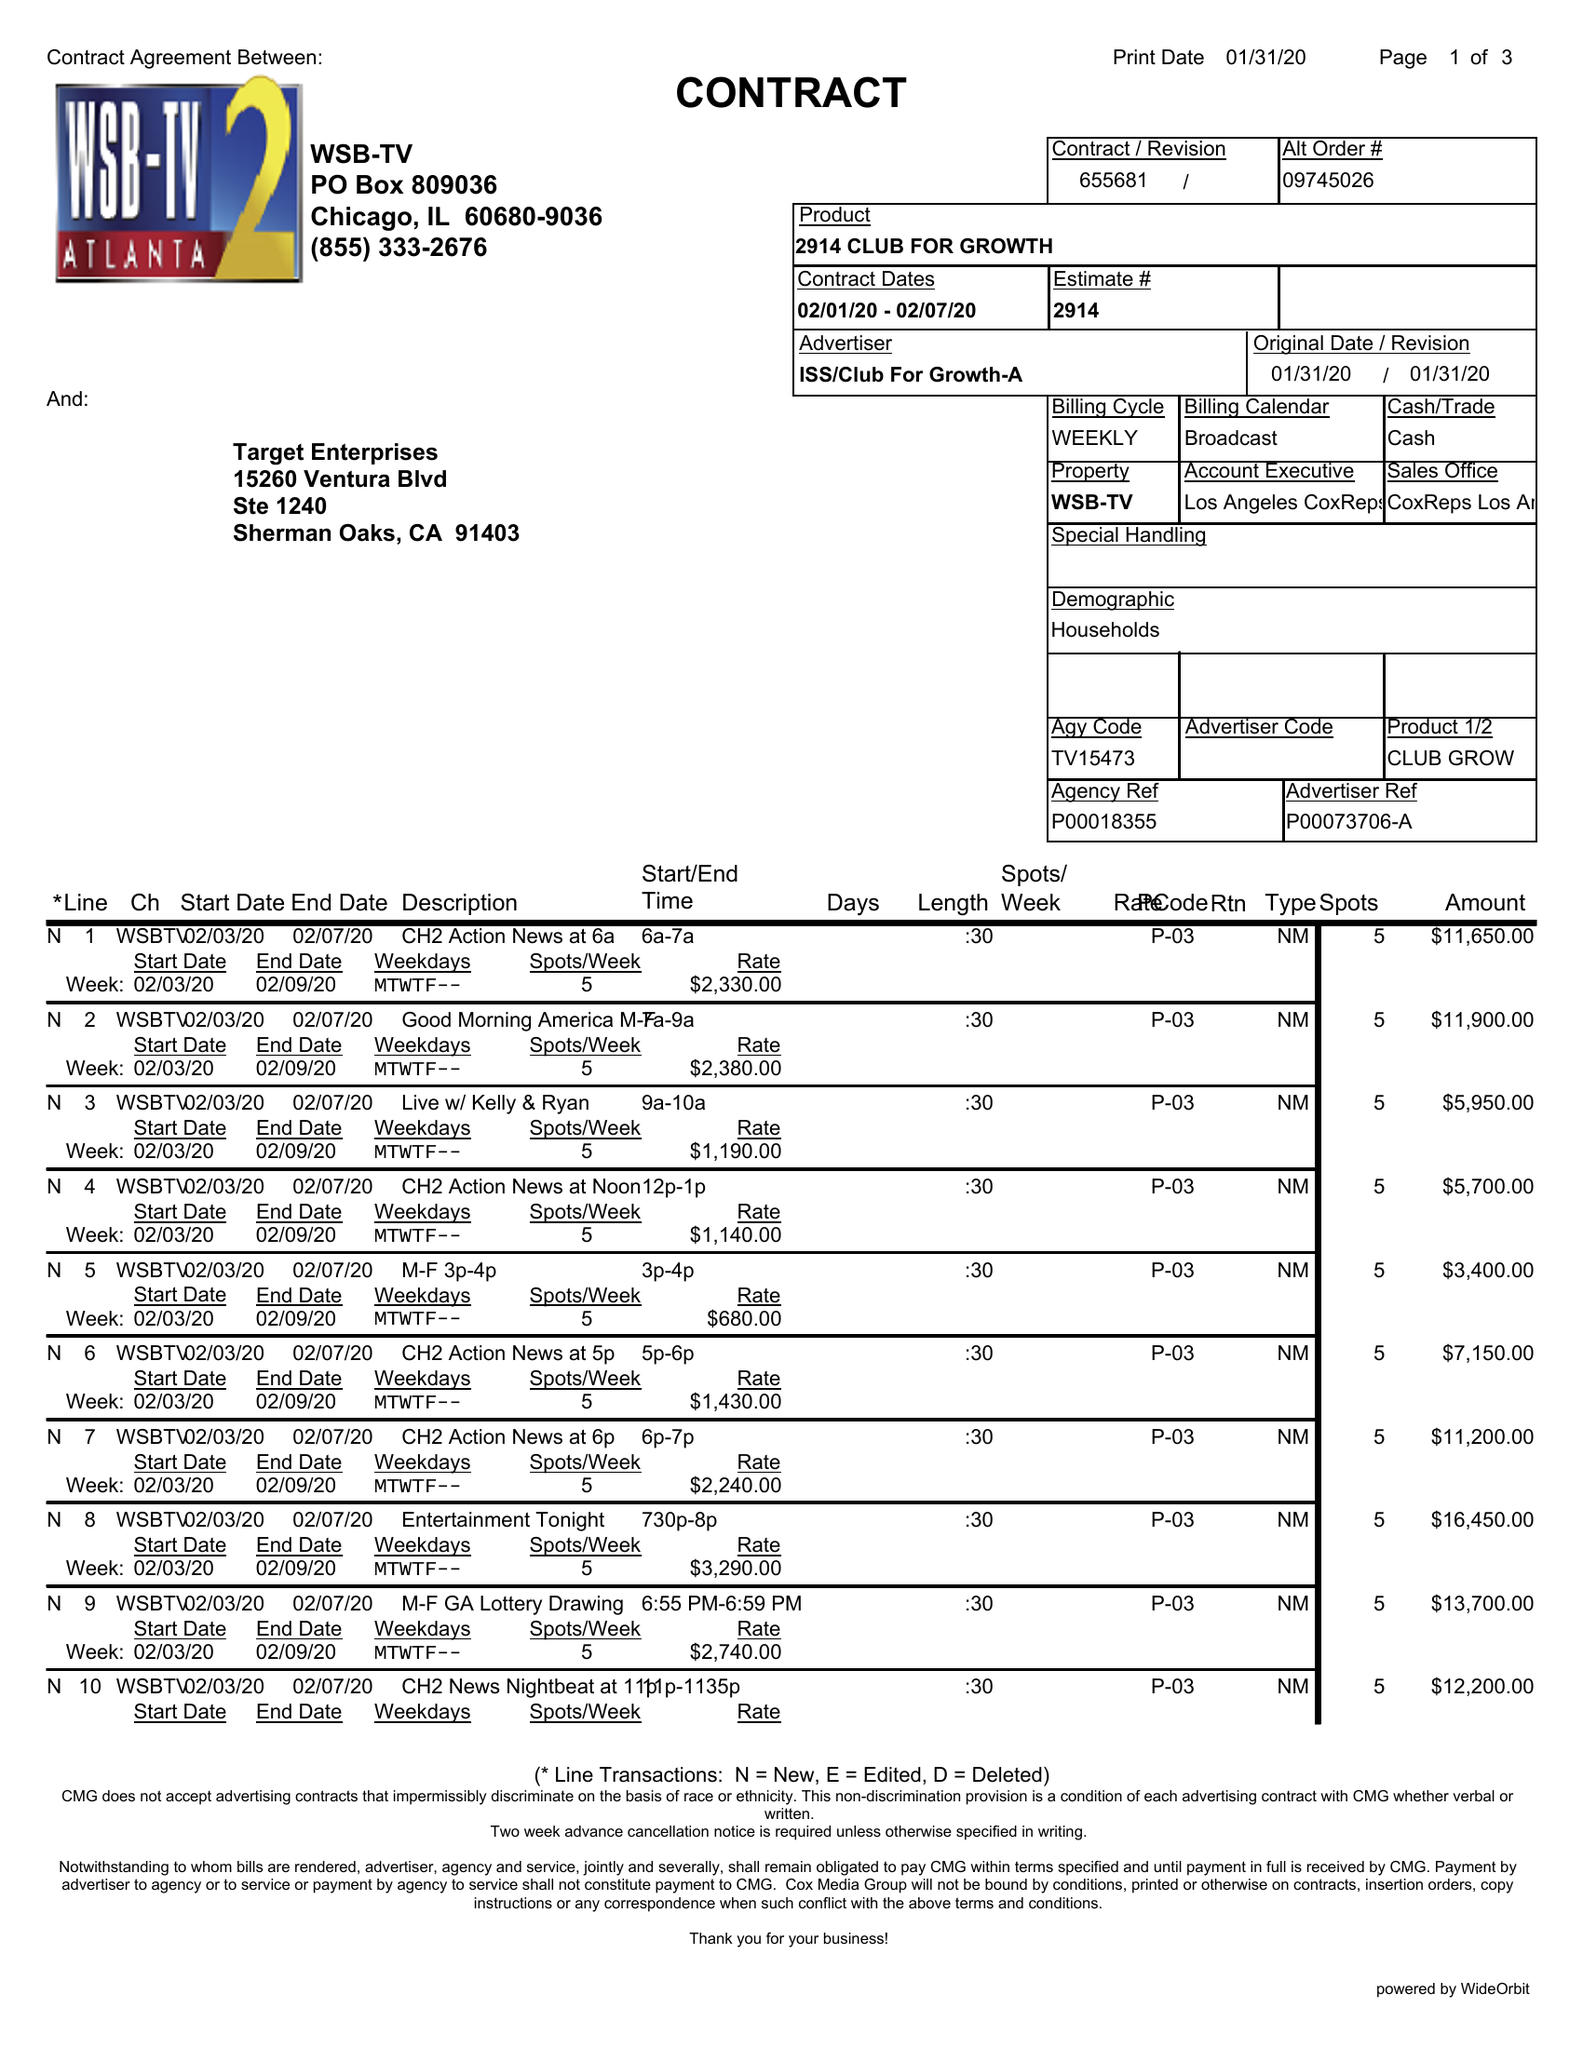What is the value for the contract_num?
Answer the question using a single word or phrase. 655681 